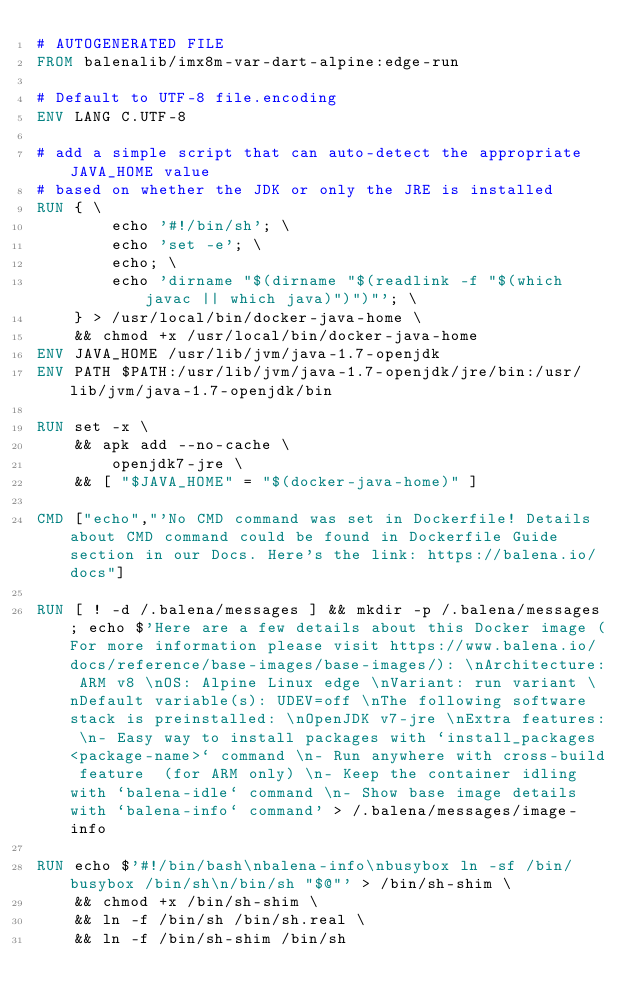Convert code to text. <code><loc_0><loc_0><loc_500><loc_500><_Dockerfile_># AUTOGENERATED FILE
FROM balenalib/imx8m-var-dart-alpine:edge-run

# Default to UTF-8 file.encoding
ENV LANG C.UTF-8

# add a simple script that can auto-detect the appropriate JAVA_HOME value
# based on whether the JDK or only the JRE is installed
RUN { \
		echo '#!/bin/sh'; \
		echo 'set -e'; \
		echo; \
		echo 'dirname "$(dirname "$(readlink -f "$(which javac || which java)")")"'; \
	} > /usr/local/bin/docker-java-home \
	&& chmod +x /usr/local/bin/docker-java-home
ENV JAVA_HOME /usr/lib/jvm/java-1.7-openjdk
ENV PATH $PATH:/usr/lib/jvm/java-1.7-openjdk/jre/bin:/usr/lib/jvm/java-1.7-openjdk/bin

RUN set -x \
	&& apk add --no-cache \
		openjdk7-jre \
	&& [ "$JAVA_HOME" = "$(docker-java-home)" ]

CMD ["echo","'No CMD command was set in Dockerfile! Details about CMD command could be found in Dockerfile Guide section in our Docs. Here's the link: https://balena.io/docs"]

RUN [ ! -d /.balena/messages ] && mkdir -p /.balena/messages; echo $'Here are a few details about this Docker image (For more information please visit https://www.balena.io/docs/reference/base-images/base-images/): \nArchitecture: ARM v8 \nOS: Alpine Linux edge \nVariant: run variant \nDefault variable(s): UDEV=off \nThe following software stack is preinstalled: \nOpenJDK v7-jre \nExtra features: \n- Easy way to install packages with `install_packages <package-name>` command \n- Run anywhere with cross-build feature  (for ARM only) \n- Keep the container idling with `balena-idle` command \n- Show base image details with `balena-info` command' > /.balena/messages/image-info

RUN echo $'#!/bin/bash\nbalena-info\nbusybox ln -sf /bin/busybox /bin/sh\n/bin/sh "$@"' > /bin/sh-shim \
	&& chmod +x /bin/sh-shim \
	&& ln -f /bin/sh /bin/sh.real \
	&& ln -f /bin/sh-shim /bin/sh</code> 